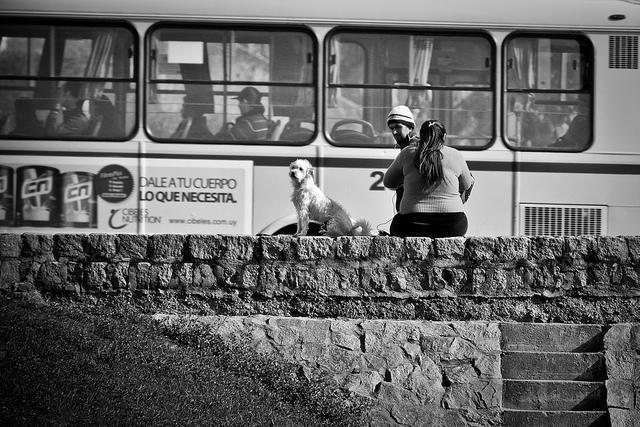How many people are not in the bus?
Give a very brief answer. 2. How many dogs can be seen?
Give a very brief answer. 1. How many orange and white cats are in the image?
Give a very brief answer. 0. 